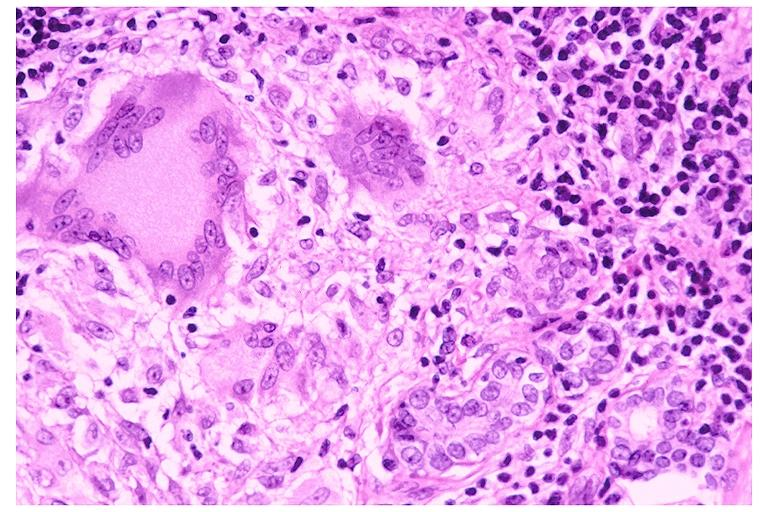does thymoma show sarcoidosis?
Answer the question using a single word or phrase. No 